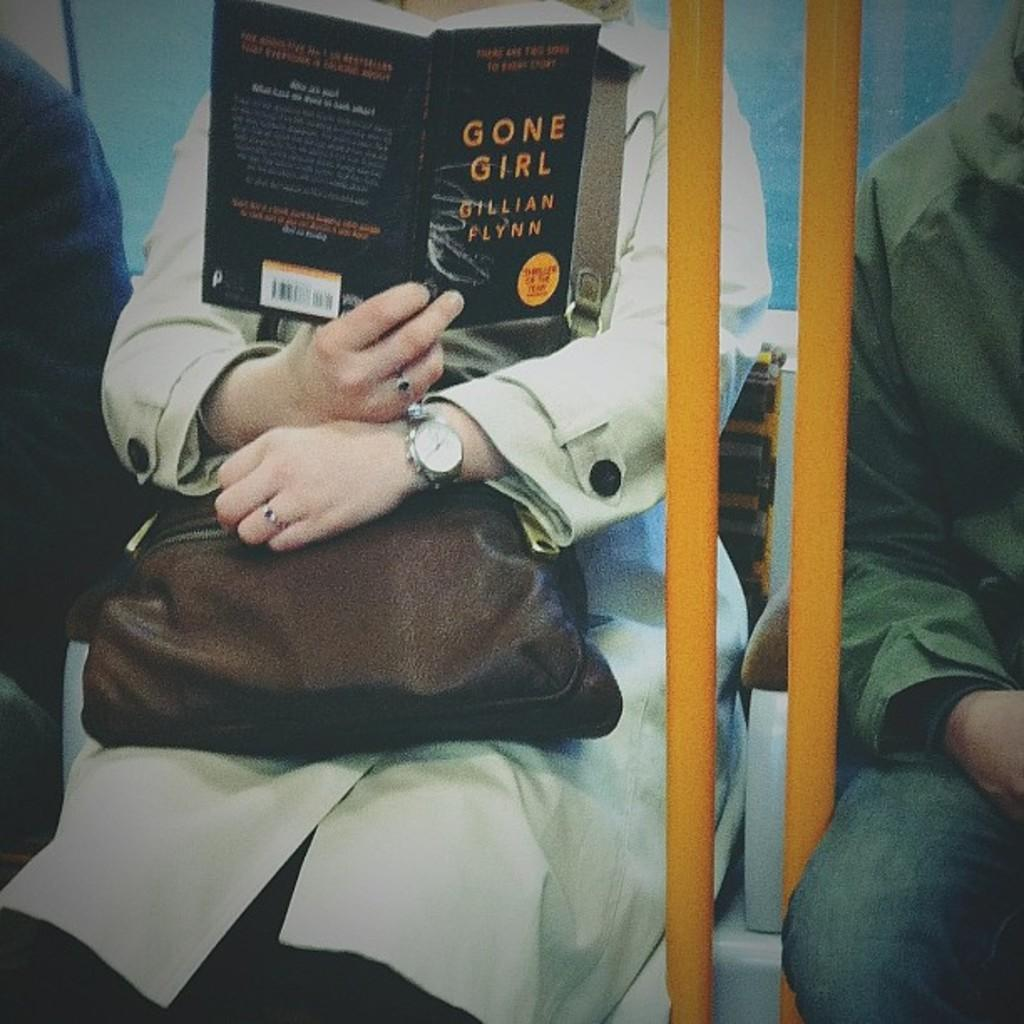Provide a one-sentence caption for the provided image. A woman on a subway reads Gone Girl by Gillian Flynn while she holds her purse. 